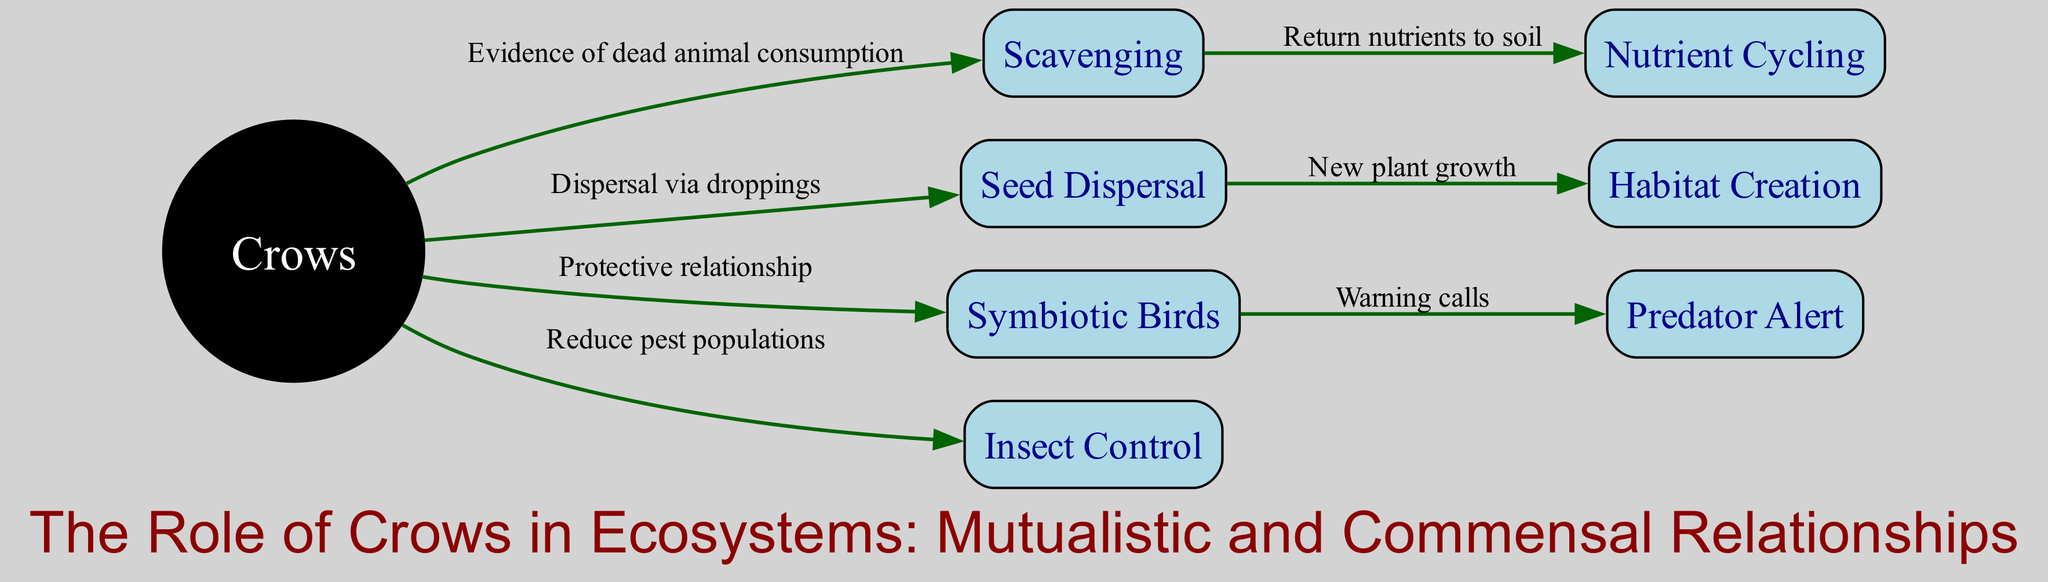What is the central node in the diagram? The central node is "Crows," as it connects to multiple other nodes directly and is clearly highlighted in the diagram by its circle shape and black color.
Answer: Crows How many nodes are present in the diagram? The diagram includes a total of eight nodes, which are uniquely listed. Counting each node gives us the final tally.
Answer: 8 What relationship does "Crows" have with "Scavenging"? "Crows" has a direct relationship with "Scavenging," indicated by an edge that describes their role in the consumption of dead animals.
Answer: Evidence of dead animal consumption What is the ultimate effect of "Seed Dispersal" in the diagram? The ultimate effect of "Seed Dispersal" is "Habitat Creation." This is described in the edge that shows how new plant growth arises from seed dispersal.
Answer: Habitat Creation How many edges connect to the node "Crows"? The node "Crows" has four edges connecting it to other nodes. Each edge represents a specific relationship between "Crows" and the linked concepts.
Answer: 4 Which node is connected to "Symbiotic Birds"? "Symbiotic Birds" connects to "Predator Alert," as shown in the diagram with an edge that indicates the role of warning calls between the two nodes.
Answer: Predator Alert What role do crows play in "Insect Control"? Crows reduce pest populations, which is an important role outlined in the diagram through a direct line from "Crows" to "Insect Control."
Answer: Reduce pest populations What process do crows contribute to that returns nutrients to the soil? Crows contribute to "Nutrient Cycling" by participating in "Scavenging," which leads to the return of nutrients to the soil. This is shown by the connecting edge in the diagram.
Answer: Nutrient Cycling What is the connection between "Seed Dispersal" and new plant growth? The connection is that "Seed Dispersal" leads to "Habitat Creation," as indicated by the edge that describes how the dispersal of seeds promotes new plant growth.
Answer: New plant growth 